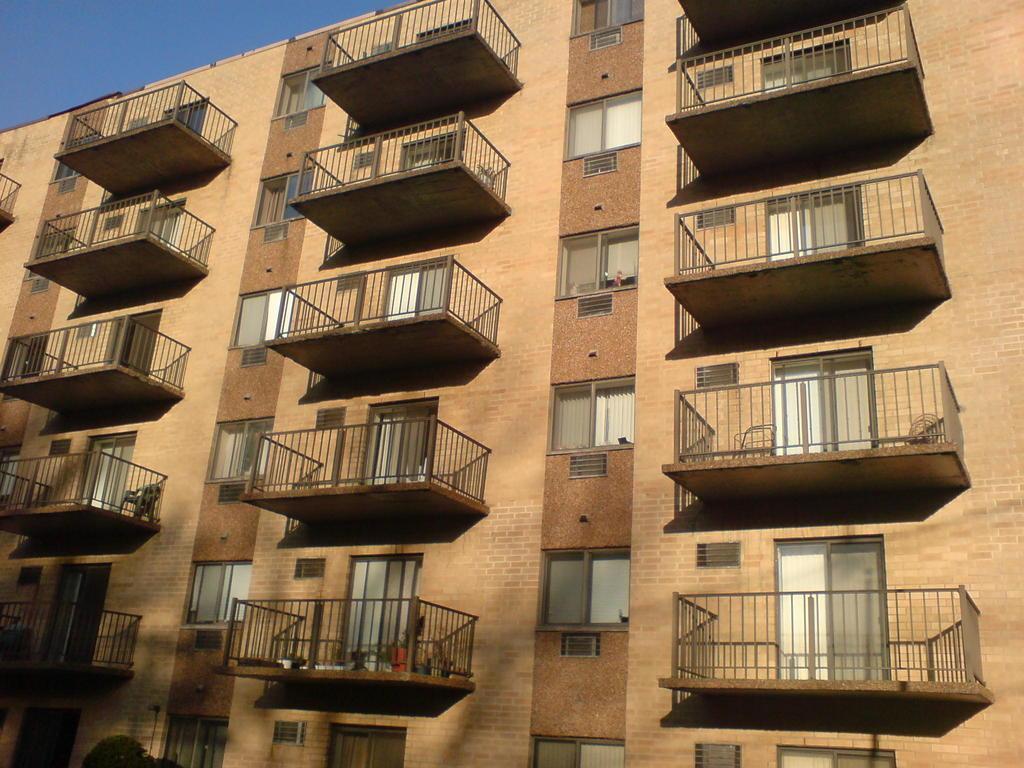Describe this image in one or two sentences. In this image we can see the building with the windows and also doors. We can also see the chair. Sky is also visible. 